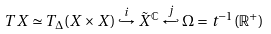<formula> <loc_0><loc_0><loc_500><loc_500>T X \simeq { T _ { \Delta } ( X \times { X } ) } \overset { i } { \hookrightarrow } \tilde { X } ^ { \mathbb { C } } \overset { j } { \hookleftarrow } \Omega = t ^ { - 1 } ( \mathbb { R } ^ { + } )</formula> 